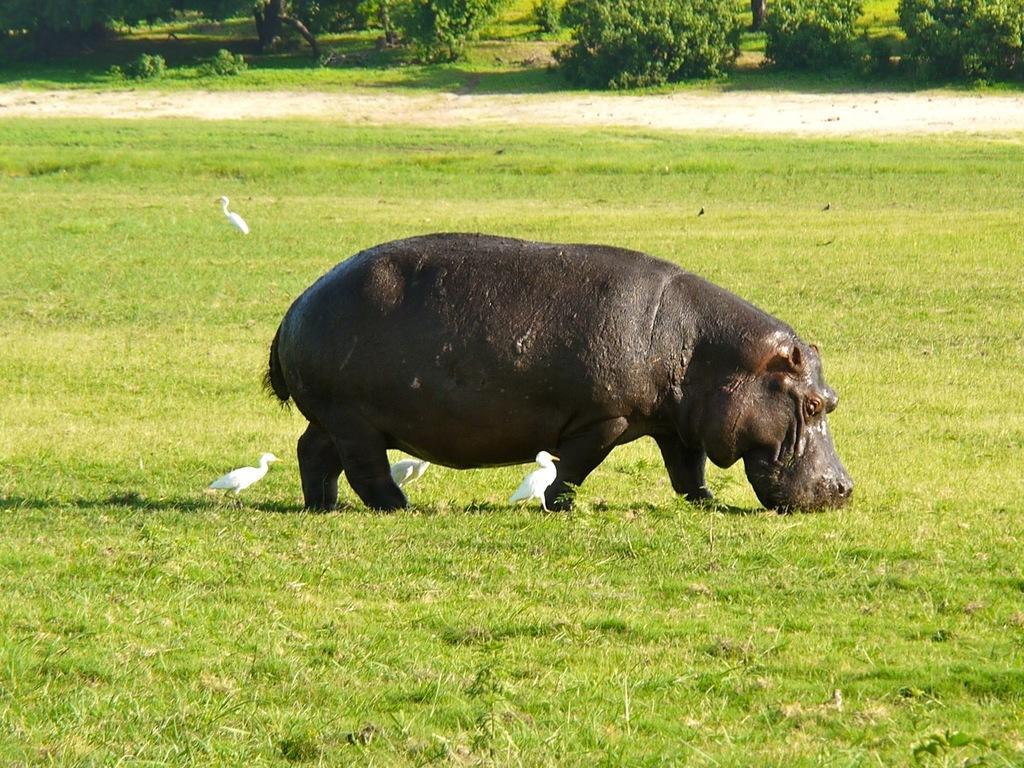Please provide a concise description of this image. In this picture we can see a hippopotamus and birds on the grass, in the background we can see trees. 